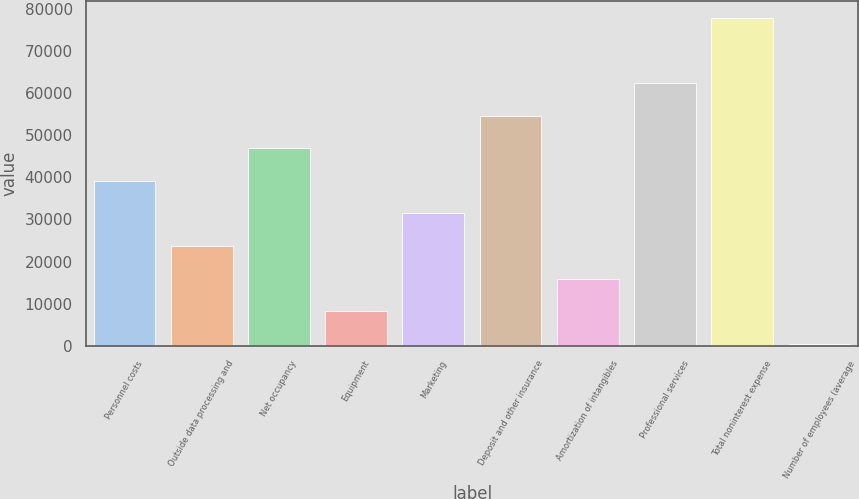Convert chart. <chart><loc_0><loc_0><loc_500><loc_500><bar_chart><fcel>Personnel costs<fcel>Outside data processing and<fcel>Net occupancy<fcel>Equipment<fcel>Marketing<fcel>Deposit and other insurance<fcel>Amortization of intangibles<fcel>Professional services<fcel>Total noninterest expense<fcel>Number of employees (average<nl><fcel>39171.5<fcel>23690.9<fcel>46911.8<fcel>8210.3<fcel>31431.2<fcel>54652.1<fcel>15950.6<fcel>62392.4<fcel>77873<fcel>470<nl></chart> 